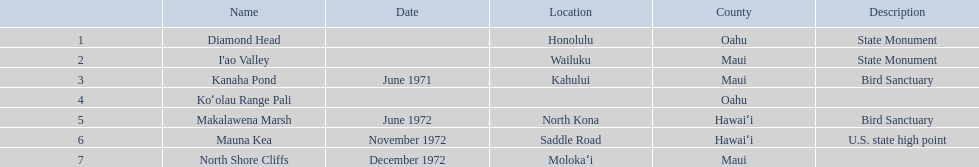What are the names of the different hawaiian national landmarks Diamond Head, I'ao Valley, Kanaha Pond, Koʻolau Range Pali, Makalawena Marsh, Mauna Kea, North Shore Cliffs. Which landmark does not have a location listed? Koʻolau Range Pali. 